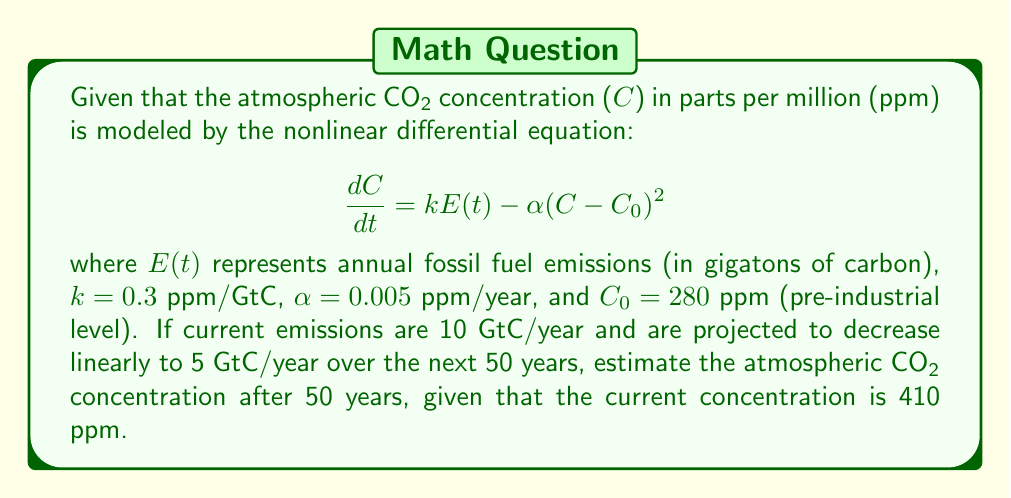Can you solve this math problem? To solve this problem, we'll follow these steps:

1) First, we need to express $E(t)$ as a function of time:
   $E(t) = 10 - 0.1t$ (decreases from 10 to 5 over 50 years)

2) Substitute this into our differential equation:
   $$\frac{dC}{dt} = 0.3(10 - 0.1t) - 0.005(C - 280)^2$$

3) This nonlinear differential equation doesn't have a simple analytical solution, so we'll use numerical methods. We can use Euler's method with a small time step, say $\Delta t = 0.1$ years.

4) Euler's method gives us:
   $C_{n+1} = C_n + \Delta t \cdot \frac{dC}{dt}|_{C=C_n}$

5) Implement this in a loop for 500 steps (50 years with 0.1-year steps):

   $C_0 = 410$
   For $n = 0$ to 499:
      $t = 0.1n$
      $\frac{dC}{dt} = 0.3(10 - 0.1t) - 0.005(C_n - 280)^2$
      $C_{n+1} = C_n + 0.1 \cdot \frac{dC}{dt}$

6) After implementing this (which would typically be done with a computer), we find that $C_{500} \approx 477$ ppm.
Answer: 477 ppm 